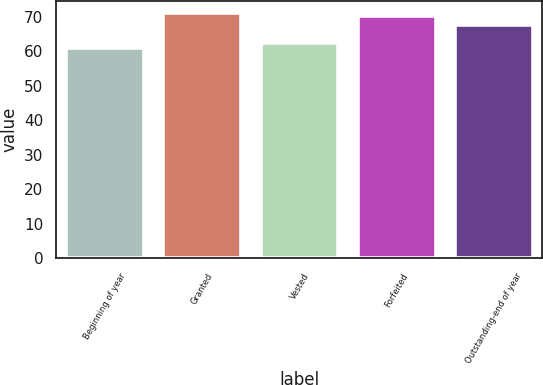Convert chart to OTSL. <chart><loc_0><loc_0><loc_500><loc_500><bar_chart><fcel>Beginning of year<fcel>Granted<fcel>Vested<fcel>Forfeited<fcel>Outstanding-end of year<nl><fcel>60.86<fcel>71.17<fcel>62.57<fcel>70.14<fcel>67.6<nl></chart> 